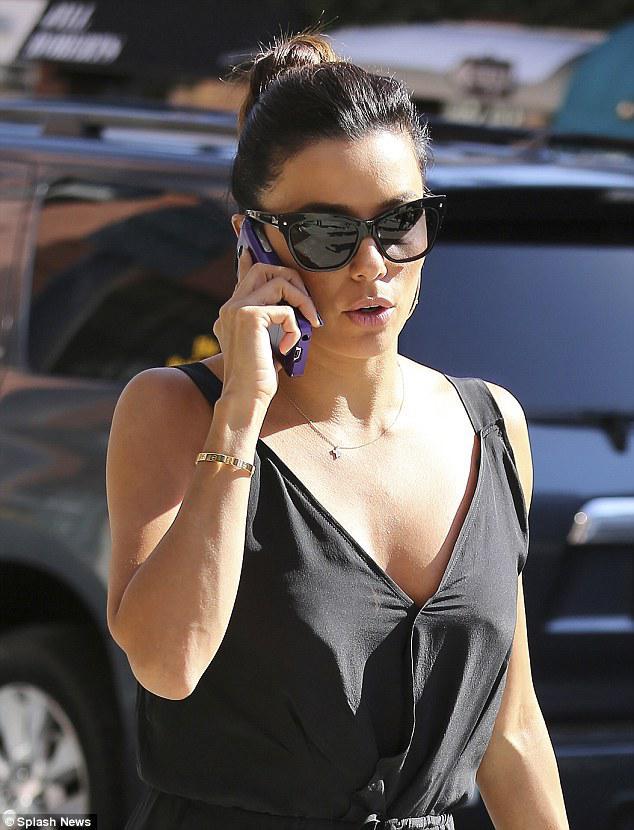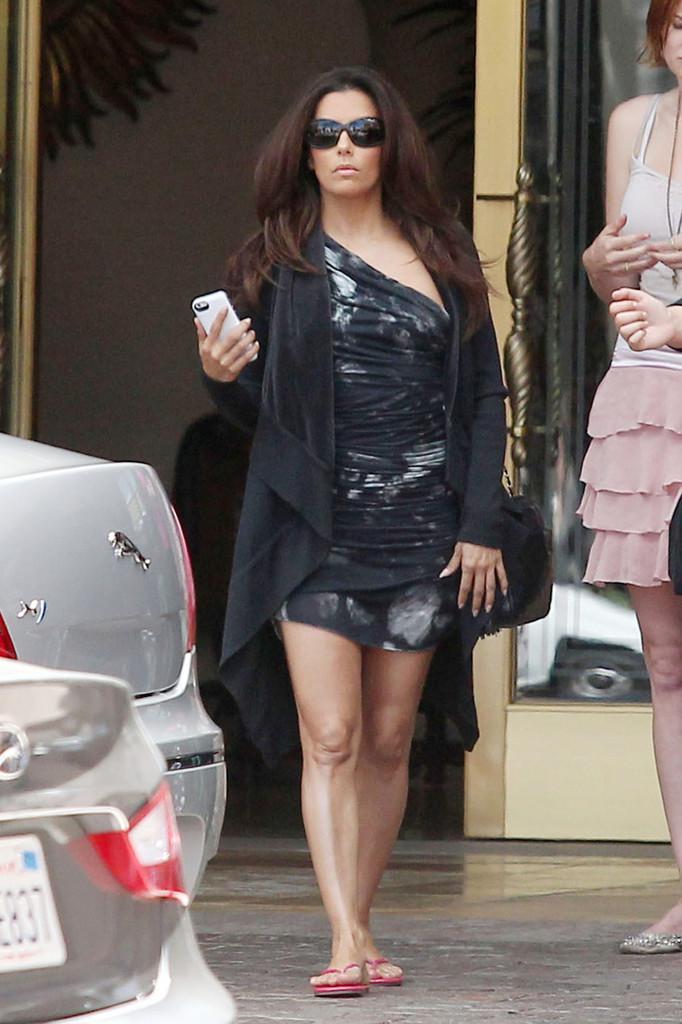The first image is the image on the left, the second image is the image on the right. Analyze the images presented: Is the assertion "Exactly one woman is talking on her phone." valid? Answer yes or no. Yes. The first image is the image on the left, the second image is the image on the right. For the images shown, is this caption "A woman is holding a cellphone to her face using her left hand." true? Answer yes or no. Yes. 